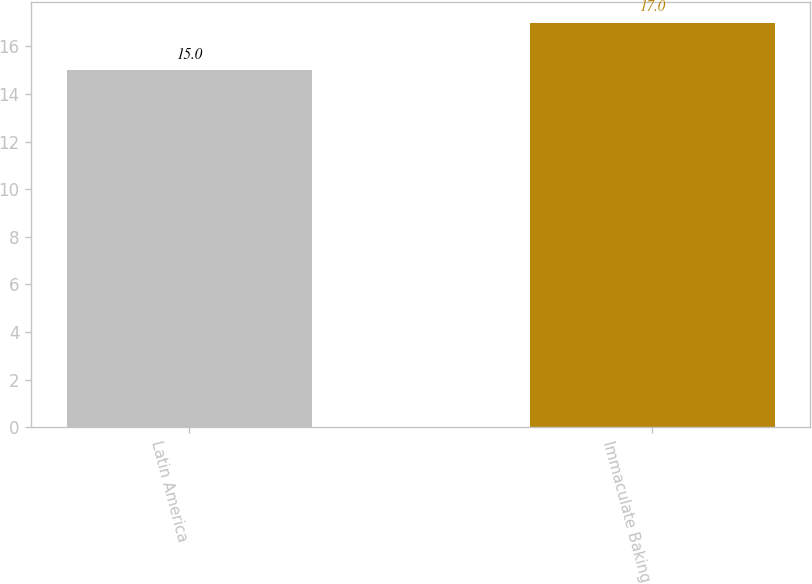Convert chart to OTSL. <chart><loc_0><loc_0><loc_500><loc_500><bar_chart><fcel>Latin America<fcel>Immaculate Baking<nl><fcel>15<fcel>17<nl></chart> 